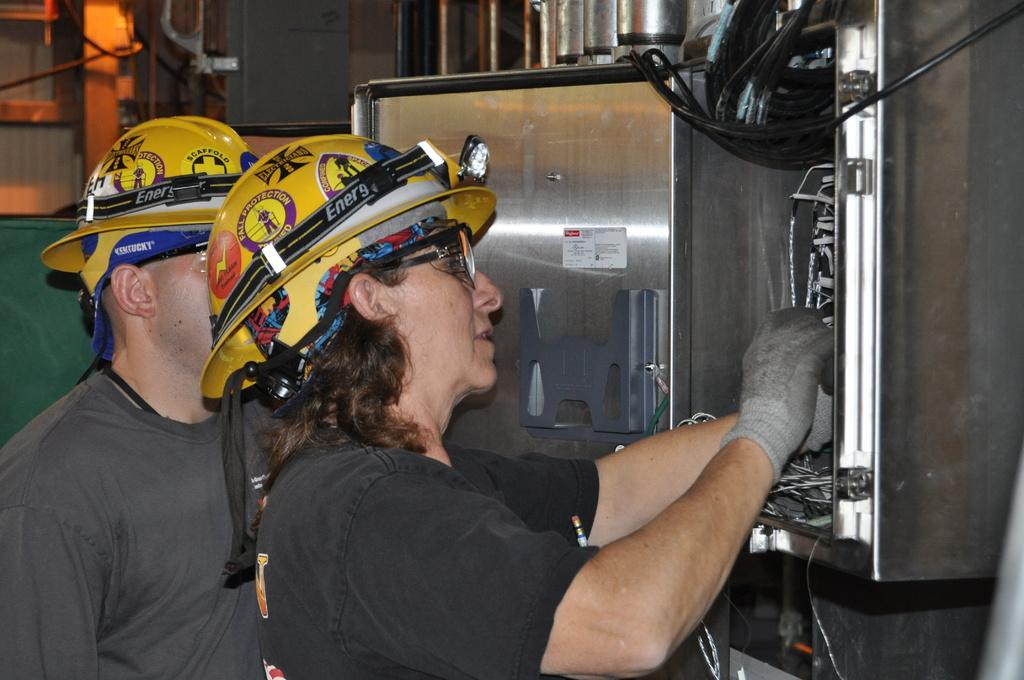How many persons are wearing helmets in the image? There are two persons with helmets in the image. What is the person in the image doing? There is a person repairing a fuse box in the image. Can you describe the background of the image? There are some objects in the background of the image. What type of vest is the person wearing while repairing the fuse box? There is no vest mentioned or visible in the image; the person is wearing a helmet and working on the fuse box. How does the love between the two persons with helmets manifest in the image? There is no indication of love or any emotional connection between the two persons with helmets in the image; they are simply wearing helmets and not interacting with each other. 